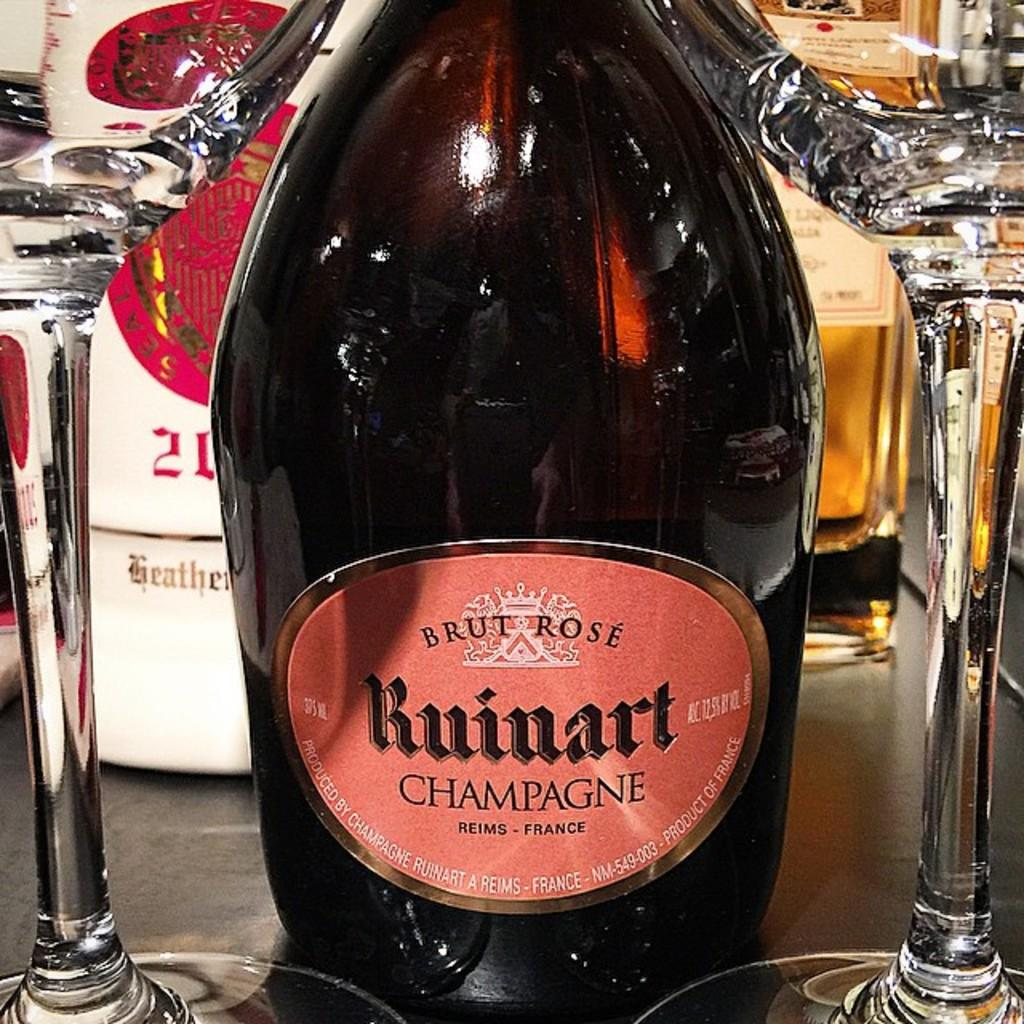<image>
Create a compact narrative representing the image presented. Black bottle with an orange label which says "Brut Rose" on it. 